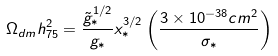Convert formula to latex. <formula><loc_0><loc_0><loc_500><loc_500>\Omega _ { d m } h _ { 7 5 } ^ { 2 } = \frac { \tilde { g } _ { * } ^ { 1 / 2 } } { g _ { * } } x _ { * } ^ { 3 / 2 } \left ( \frac { 3 \times 1 0 ^ { - 3 8 } c m ^ { 2 } } { \sigma _ { * } } \right )</formula> 